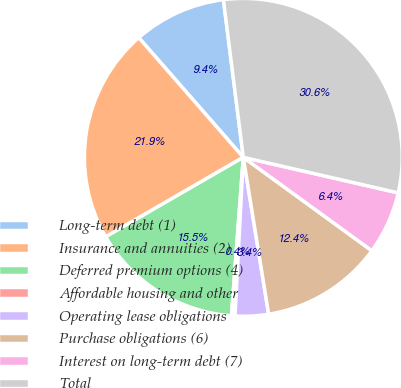<chart> <loc_0><loc_0><loc_500><loc_500><pie_chart><fcel>Long-term debt (1)<fcel>Insurance and annuities (2)<fcel>Deferred premium options (4)<fcel>Affordable housing and other<fcel>Operating lease obligations<fcel>Purchase obligations (6)<fcel>Interest on long-term debt (7)<fcel>Total<nl><fcel>9.43%<fcel>21.91%<fcel>15.47%<fcel>0.36%<fcel>3.38%<fcel>12.45%<fcel>6.41%<fcel>30.59%<nl></chart> 